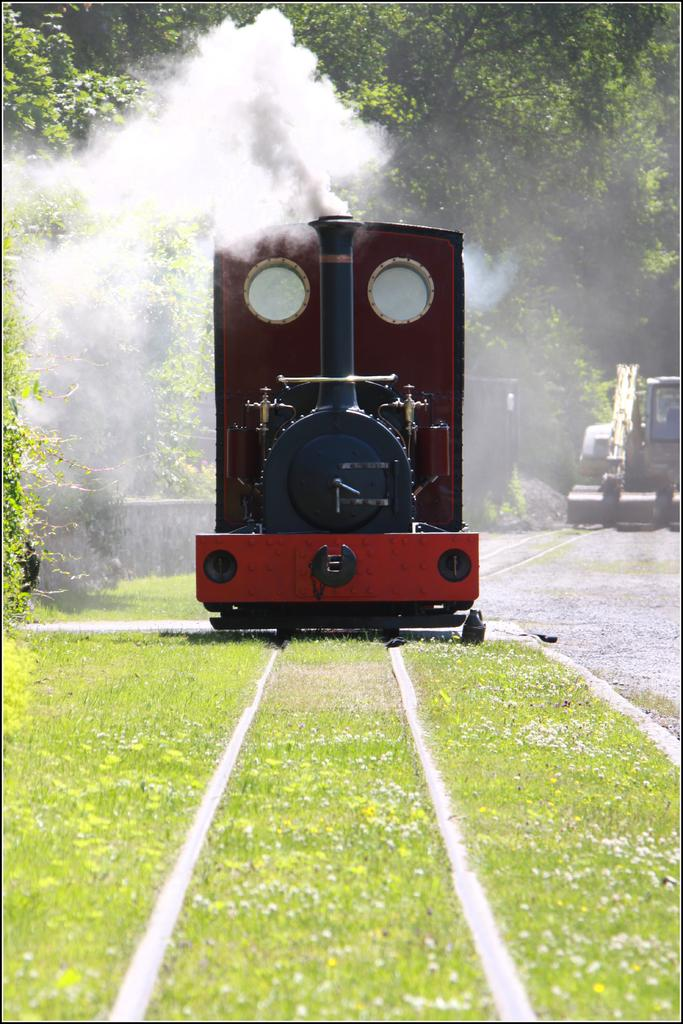What is the main subject of the image? There is a train in the image. What type of natural environment is visible in the image? There is grass and trees in the image. What type of man-made structure can be seen in the image? There is a road in the image. What is located on the right side of the image? There is a vehicle on the right side of the image. How does the train start in the image? The image does not show the train starting; it only shows the train itself. What type of support is the train using to stay elevated in the image? The train is not elevated in the image, and there is no visible support for it. 